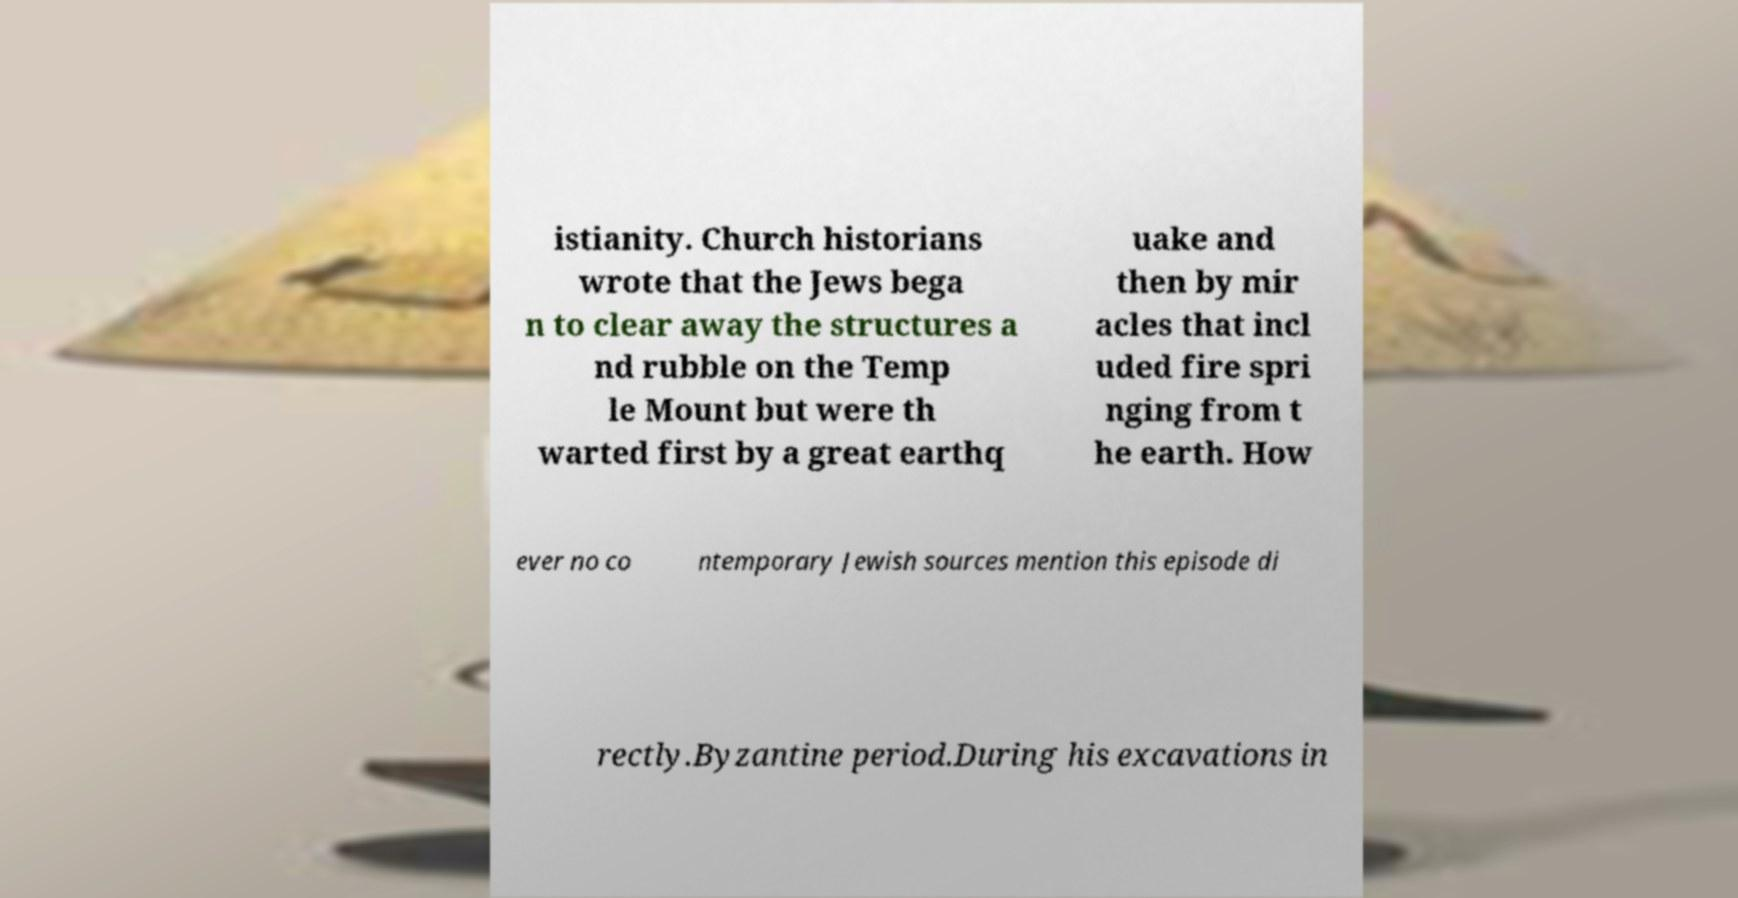For documentation purposes, I need the text within this image transcribed. Could you provide that? istianity. Church historians wrote that the Jews bega n to clear away the structures a nd rubble on the Temp le Mount but were th warted first by a great earthq uake and then by mir acles that incl uded fire spri nging from t he earth. How ever no co ntemporary Jewish sources mention this episode di rectly.Byzantine period.During his excavations in 